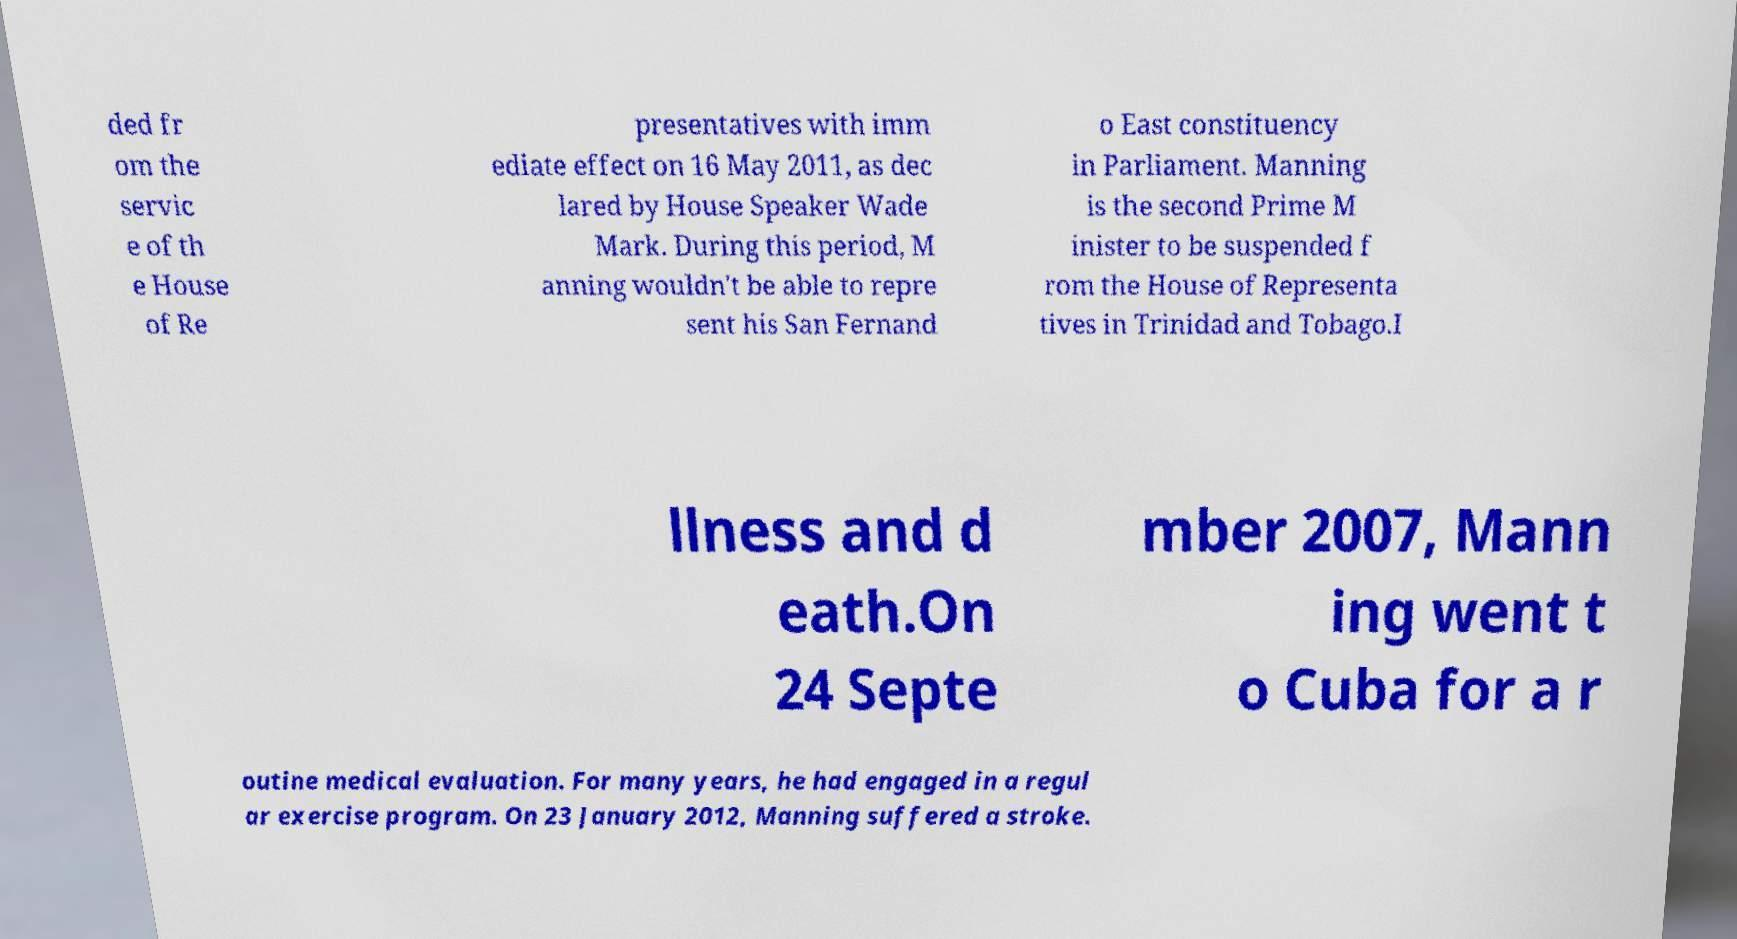Please read and relay the text visible in this image. What does it say? ded fr om the servic e of th e House of Re presentatives with imm ediate effect on 16 May 2011, as dec lared by House Speaker Wade Mark. During this period, M anning wouldn't be able to repre sent his San Fernand o East constituency in Parliament. Manning is the second Prime M inister to be suspended f rom the House of Representa tives in Trinidad and Tobago.I llness and d eath.On 24 Septe mber 2007, Mann ing went t o Cuba for a r outine medical evaluation. For many years, he had engaged in a regul ar exercise program. On 23 January 2012, Manning suffered a stroke. 